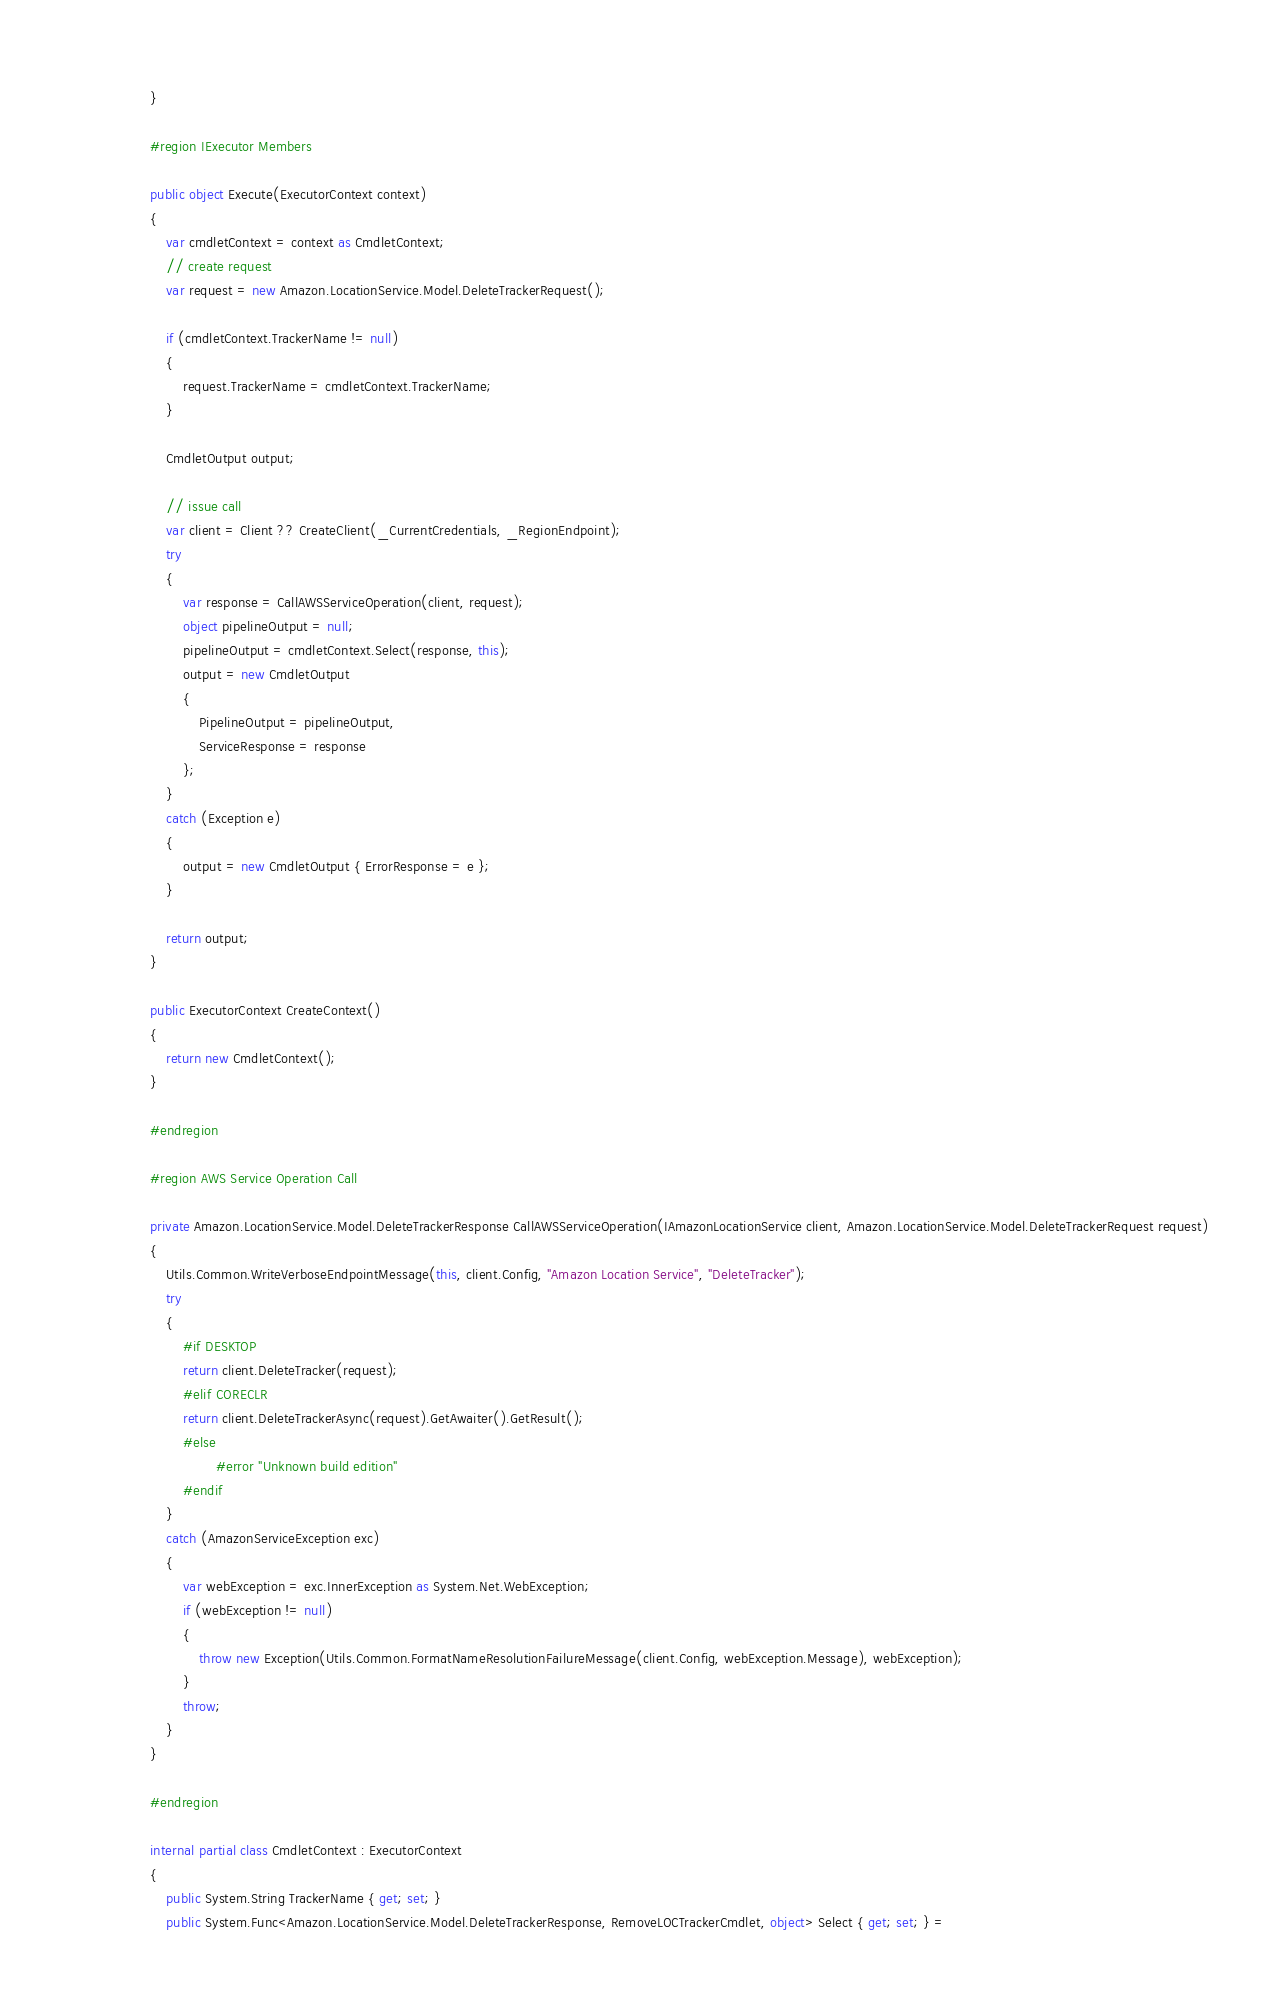<code> <loc_0><loc_0><loc_500><loc_500><_C#_>        }
        
        #region IExecutor Members
        
        public object Execute(ExecutorContext context)
        {
            var cmdletContext = context as CmdletContext;
            // create request
            var request = new Amazon.LocationService.Model.DeleteTrackerRequest();
            
            if (cmdletContext.TrackerName != null)
            {
                request.TrackerName = cmdletContext.TrackerName;
            }
            
            CmdletOutput output;
            
            // issue call
            var client = Client ?? CreateClient(_CurrentCredentials, _RegionEndpoint);
            try
            {
                var response = CallAWSServiceOperation(client, request);
                object pipelineOutput = null;
                pipelineOutput = cmdletContext.Select(response, this);
                output = new CmdletOutput
                {
                    PipelineOutput = pipelineOutput,
                    ServiceResponse = response
                };
            }
            catch (Exception e)
            {
                output = new CmdletOutput { ErrorResponse = e };
            }
            
            return output;
        }
        
        public ExecutorContext CreateContext()
        {
            return new CmdletContext();
        }
        
        #endregion
        
        #region AWS Service Operation Call
        
        private Amazon.LocationService.Model.DeleteTrackerResponse CallAWSServiceOperation(IAmazonLocationService client, Amazon.LocationService.Model.DeleteTrackerRequest request)
        {
            Utils.Common.WriteVerboseEndpointMessage(this, client.Config, "Amazon Location Service", "DeleteTracker");
            try
            {
                #if DESKTOP
                return client.DeleteTracker(request);
                #elif CORECLR
                return client.DeleteTrackerAsync(request).GetAwaiter().GetResult();
                #else
                        #error "Unknown build edition"
                #endif
            }
            catch (AmazonServiceException exc)
            {
                var webException = exc.InnerException as System.Net.WebException;
                if (webException != null)
                {
                    throw new Exception(Utils.Common.FormatNameResolutionFailureMessage(client.Config, webException.Message), webException);
                }
                throw;
            }
        }
        
        #endregion
        
        internal partial class CmdletContext : ExecutorContext
        {
            public System.String TrackerName { get; set; }
            public System.Func<Amazon.LocationService.Model.DeleteTrackerResponse, RemoveLOCTrackerCmdlet, object> Select { get; set; } =</code> 